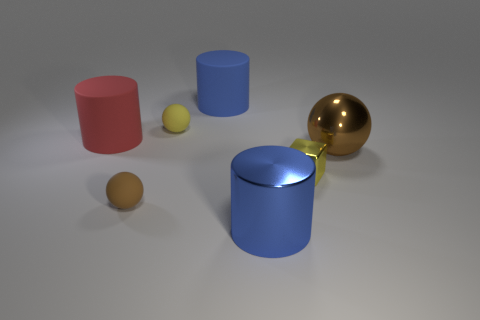Subtract all cyan cylinders. Subtract all red cubes. How many cylinders are left? 3 Add 3 brown spheres. How many objects exist? 10 Subtract all cubes. How many objects are left? 6 Subtract 0 green blocks. How many objects are left? 7 Subtract all small cubes. Subtract all yellow matte spheres. How many objects are left? 5 Add 6 yellow balls. How many yellow balls are left? 7 Add 2 big brown metallic cylinders. How many big brown metallic cylinders exist? 2 